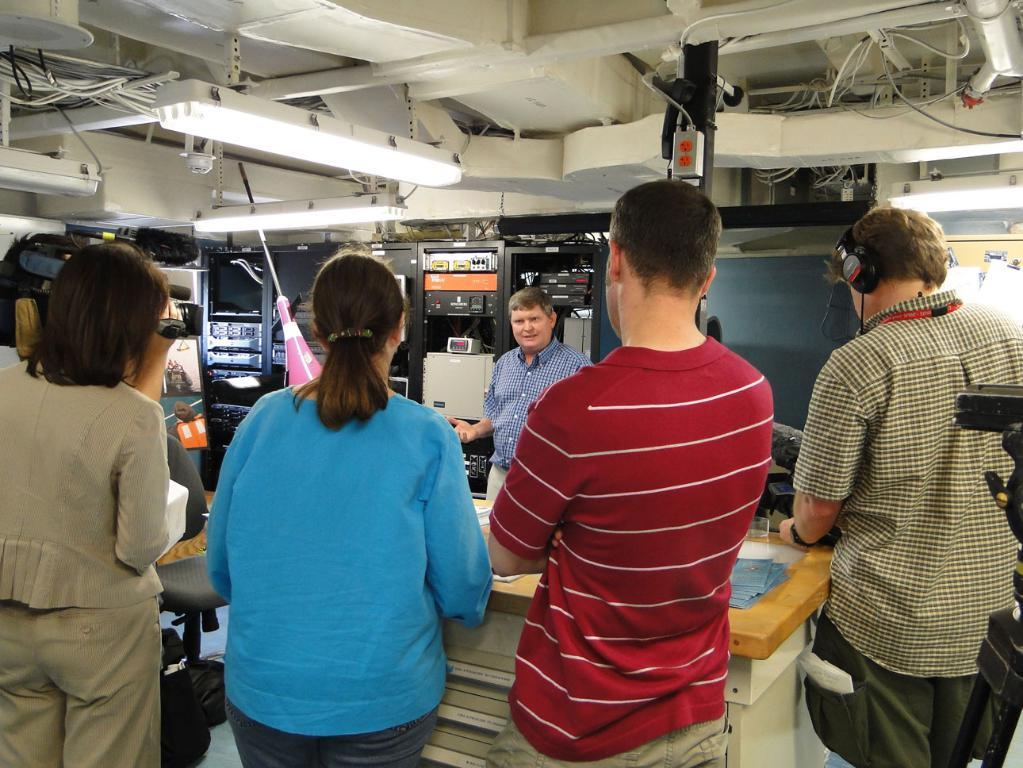How many people are in the image? There are persons in the image, but the exact number is not specified. What is the main object in the image? There is a table in the image. What can be seen in the background of the image? There are objects visible in the background of the image. What type of illumination is present in the image? There are lights in the image. What type of steam is coming from the grandmother's teapot in the image? There is no grandmother or teapot present in the image, so it is not possible to answer that question. 